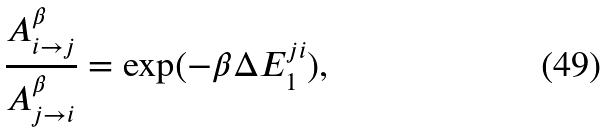<formula> <loc_0><loc_0><loc_500><loc_500>\frac { A _ { i \to j } ^ { \beta } } { A _ { j \to i } ^ { \beta } } = \exp ( - \beta \Delta E _ { 1 } ^ { j i } ) ,</formula> 